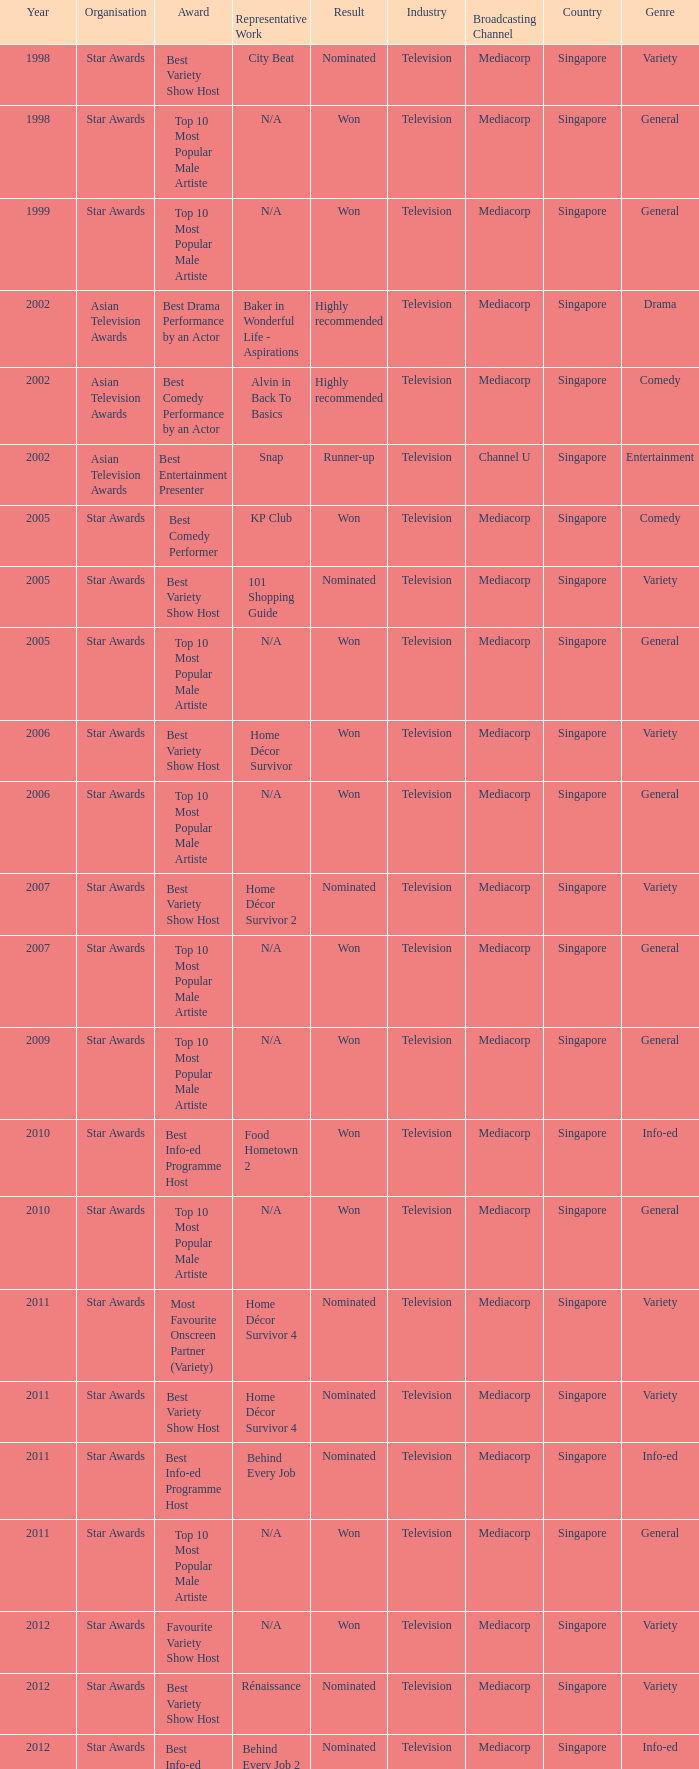What is the name of the award in a year more than 2005, and the Result of nominated? Best Variety Show Host, Most Favourite Onscreen Partner (Variety), Best Variety Show Host, Best Info-ed Programme Host, Best Variety Show Host, Best Info-ed Programme Host, Best Info-Ed Programme Host, Best Variety Show Host. 